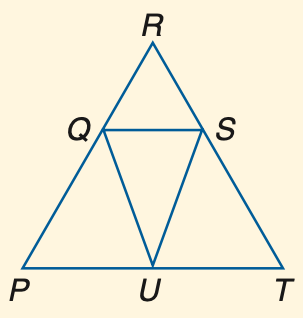Answer the mathemtical geometry problem and directly provide the correct option letter.
Question: If P Q \cong U Q, P R \cong R T and m \angle P Q U = 40, find m \angle R.
Choices: A: 40 B: 50 C: 60 D: 70 A 